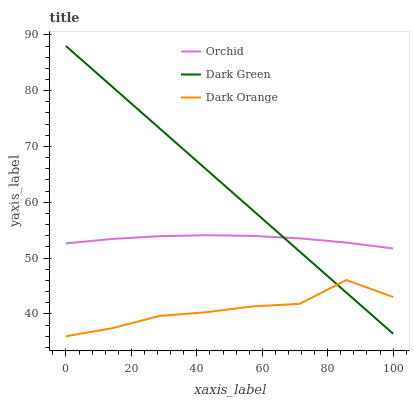Does Dark Orange have the minimum area under the curve?
Answer yes or no. Yes. Does Dark Green have the maximum area under the curve?
Answer yes or no. Yes. Does Orchid have the minimum area under the curve?
Answer yes or no. No. Does Orchid have the maximum area under the curve?
Answer yes or no. No. Is Dark Green the smoothest?
Answer yes or no. Yes. Is Dark Orange the roughest?
Answer yes or no. Yes. Is Orchid the smoothest?
Answer yes or no. No. Is Orchid the roughest?
Answer yes or no. No. Does Dark Orange have the lowest value?
Answer yes or no. Yes. Does Dark Green have the lowest value?
Answer yes or no. No. Does Dark Green have the highest value?
Answer yes or no. Yes. Does Orchid have the highest value?
Answer yes or no. No. Is Dark Orange less than Orchid?
Answer yes or no. Yes. Is Orchid greater than Dark Orange?
Answer yes or no. Yes. Does Dark Green intersect Dark Orange?
Answer yes or no. Yes. Is Dark Green less than Dark Orange?
Answer yes or no. No. Is Dark Green greater than Dark Orange?
Answer yes or no. No. Does Dark Orange intersect Orchid?
Answer yes or no. No. 